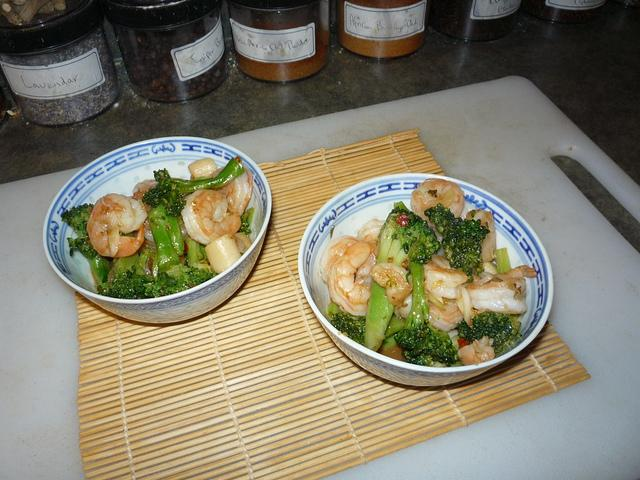If this is Chinese food how was it most likely cooked? Please explain your reasoning. stir fried. The chinese food was probably stir fried as this is a common cooking technique in that cuisine. 